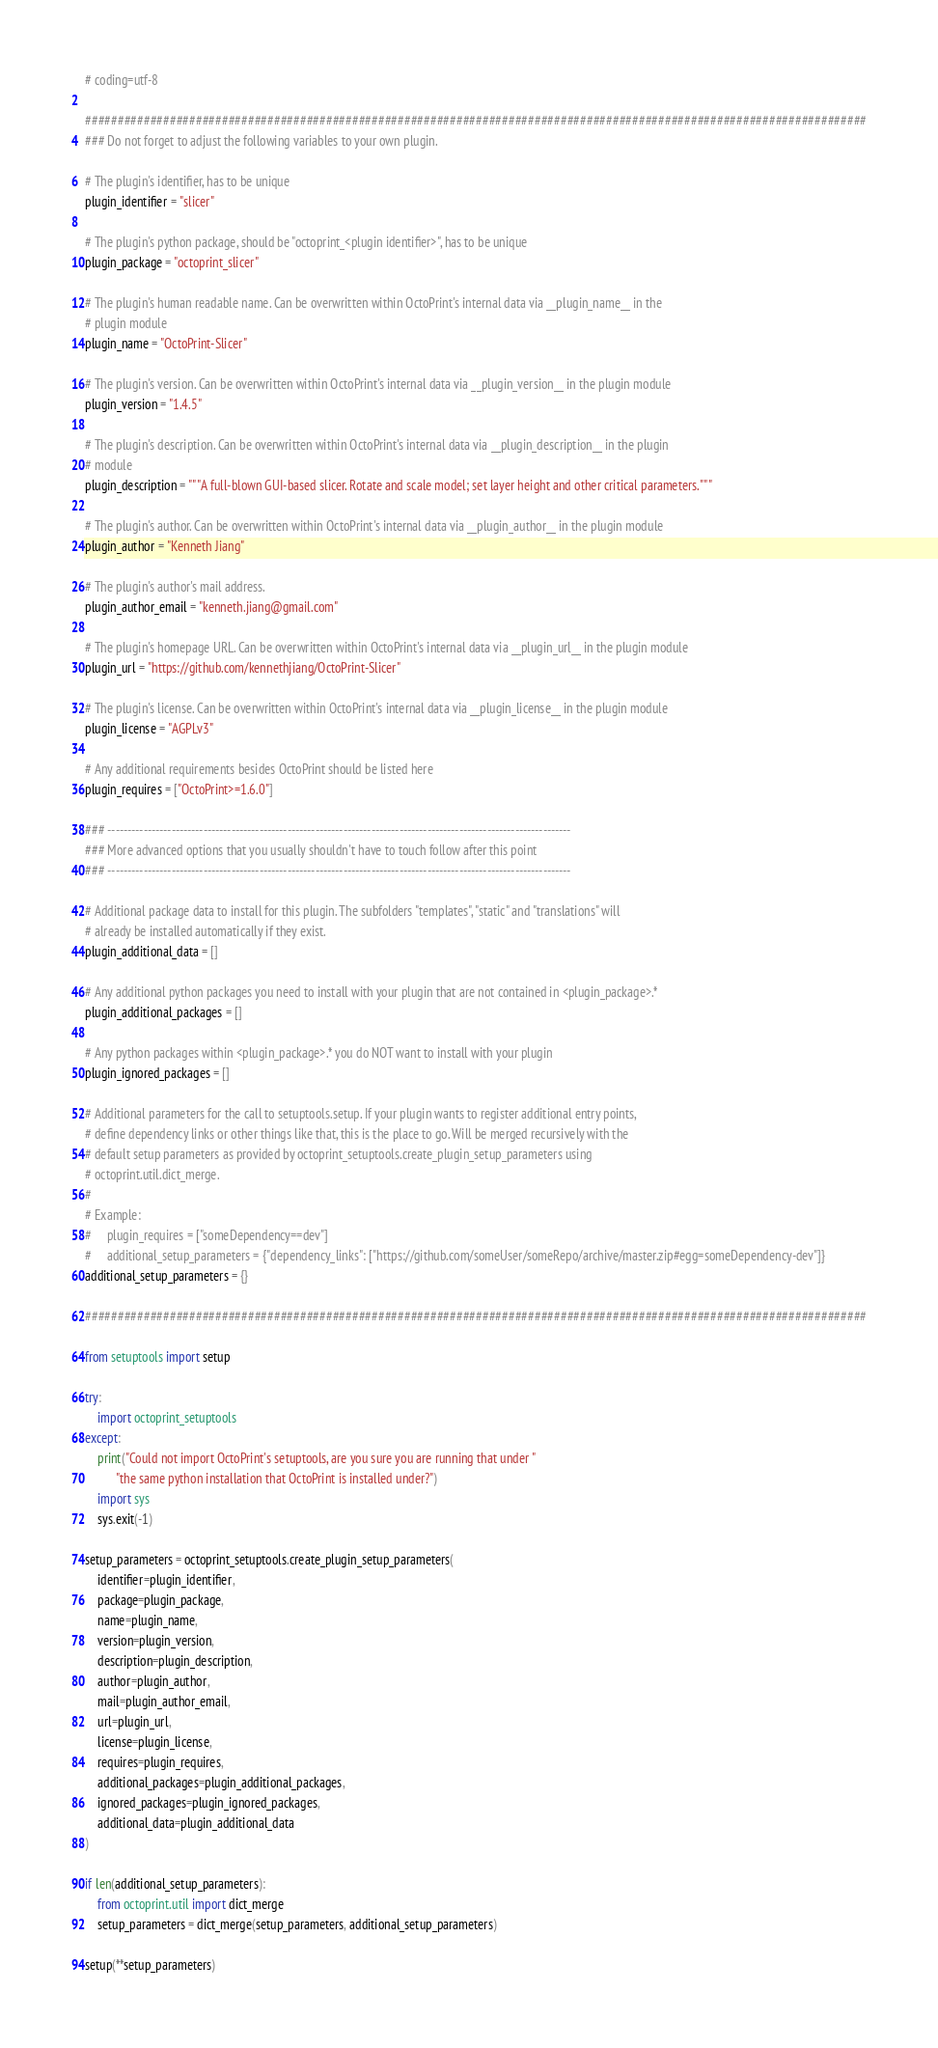<code> <loc_0><loc_0><loc_500><loc_500><_Python_># coding=utf-8

########################################################################################################################
### Do not forget to adjust the following variables to your own plugin.

# The plugin's identifier, has to be unique
plugin_identifier = "slicer"

# The plugin's python package, should be "octoprint_<plugin identifier>", has to be unique
plugin_package = "octoprint_slicer"

# The plugin's human readable name. Can be overwritten within OctoPrint's internal data via __plugin_name__ in the
# plugin module
plugin_name = "OctoPrint-Slicer"

# The plugin's version. Can be overwritten within OctoPrint's internal data via __plugin_version__ in the plugin module
plugin_version = "1.4.5"

# The plugin's description. Can be overwritten within OctoPrint's internal data via __plugin_description__ in the plugin
# module
plugin_description = """A full-blown GUI-based slicer. Rotate and scale model; set layer height and other critical parameters."""

# The plugin's author. Can be overwritten within OctoPrint's internal data via __plugin_author__ in the plugin module
plugin_author = "Kenneth Jiang"

# The plugin's author's mail address.
plugin_author_email = "kenneth.jiang@gmail.com"

# The plugin's homepage URL. Can be overwritten within OctoPrint's internal data via __plugin_url__ in the plugin module
plugin_url = "https://github.com/kennethjiang/OctoPrint-Slicer"

# The plugin's license. Can be overwritten within OctoPrint's internal data via __plugin_license__ in the plugin module
plugin_license = "AGPLv3"

# Any additional requirements besides OctoPrint should be listed here
plugin_requires = ["OctoPrint>=1.6.0"]

### --------------------------------------------------------------------------------------------------------------------
### More advanced options that you usually shouldn't have to touch follow after this point
### --------------------------------------------------------------------------------------------------------------------

# Additional package data to install for this plugin. The subfolders "templates", "static" and "translations" will
# already be installed automatically if they exist.
plugin_additional_data = []

# Any additional python packages you need to install with your plugin that are not contained in <plugin_package>.*
plugin_additional_packages = []

# Any python packages within <plugin_package>.* you do NOT want to install with your plugin
plugin_ignored_packages = []

# Additional parameters for the call to setuptools.setup. If your plugin wants to register additional entry points,
# define dependency links or other things like that, this is the place to go. Will be merged recursively with the
# default setup parameters as provided by octoprint_setuptools.create_plugin_setup_parameters using
# octoprint.util.dict_merge.
#
# Example:
#     plugin_requires = ["someDependency==dev"]
#     additional_setup_parameters = {"dependency_links": ["https://github.com/someUser/someRepo/archive/master.zip#egg=someDependency-dev"]}
additional_setup_parameters = {}

########################################################################################################################

from setuptools import setup

try:
	import octoprint_setuptools
except:
	print("Could not import OctoPrint's setuptools, are you sure you are running that under "
	      "the same python installation that OctoPrint is installed under?")
	import sys
	sys.exit(-1)

setup_parameters = octoprint_setuptools.create_plugin_setup_parameters(
	identifier=plugin_identifier,
	package=plugin_package,
	name=plugin_name,
	version=plugin_version,
	description=plugin_description,
	author=plugin_author,
	mail=plugin_author_email,
	url=plugin_url,
	license=plugin_license,
	requires=plugin_requires,
	additional_packages=plugin_additional_packages,
	ignored_packages=plugin_ignored_packages,
	additional_data=plugin_additional_data
)

if len(additional_setup_parameters):
	from octoprint.util import dict_merge
	setup_parameters = dict_merge(setup_parameters, additional_setup_parameters)

setup(**setup_parameters)
</code> 